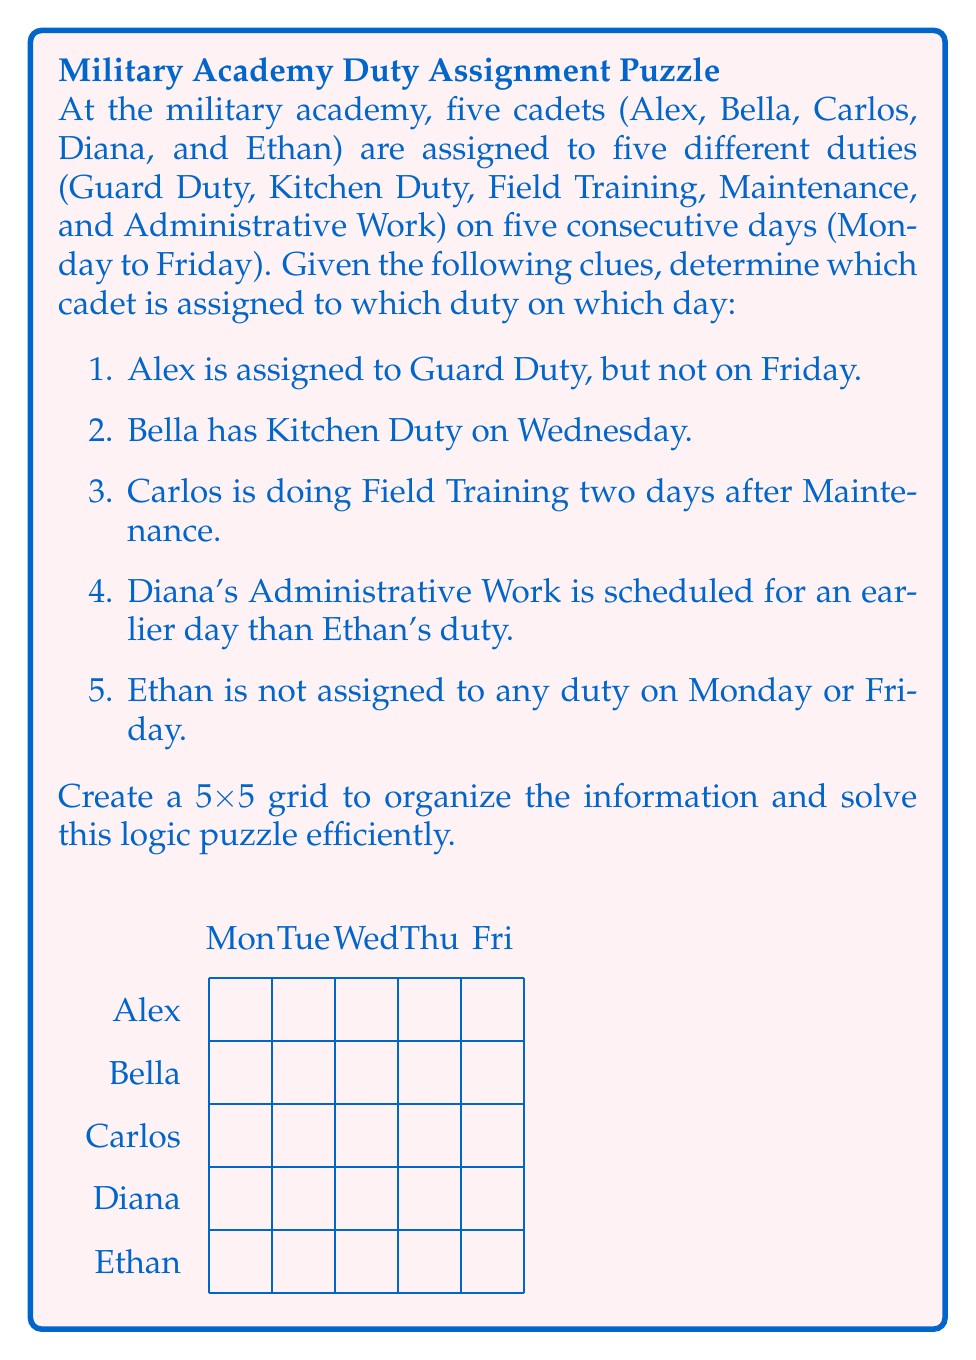What is the answer to this math problem? Let's solve this step-by-step using the given clues and process of elimination:

1. From clue 1, we know Alex has Guard Duty on either Monday, Tuesday, Wednesday, or Thursday.

2. Clue 2 gives us a definite placement: Bella has Kitchen Duty on Wednesday.

3. From clue 5, we know Ethan's duty is on Tuesday, Wednesday, or Thursday.

4. Clue 4 tells us Diana's Administrative Work is before Ethan's duty. Given point 3, Diana's duty must be on Monday or Tuesday.

5. From clue 3, we know Carlos has Field Training two days after Maintenance. The only way this works is if Maintenance is on Tuesday and Field Training is on Thursday.

6. Since Carlos has Field Training on Thursday, and we know from point 1 that Alex can't have Guard Duty on Friday, Alex must have Guard Duty on Monday.

7. This means Diana's Administrative Work must be on Tuesday (as it can't be Monday, which is taken by Alex's Guard Duty).

8. The only remaining slot for Ethan is Wednesday.

9. The only duty left for Friday is Maintenance, which must be assigned to Diana.

Now we can fill in the grid:

Monday: Alex - Guard Duty
Tuesday: Diana - Administrative Work
Wednesday: Bella - Kitchen Duty, Ethan - Field Training
Thursday: Carlos - Field Training
Friday: Diana - Maintenance
Answer: Mon: Alex (Guard), Tue: Diana (Admin), Wed: Bella (Kitchen) & Ethan (Field), Thu: Carlos (Field), Fri: Diana (Maintenance) 